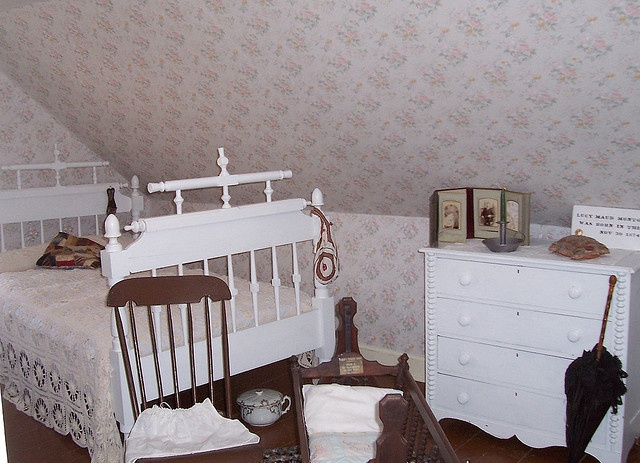Describe the objects in this image and their specific colors. I can see bed in gray, darkgray, and lightgray tones, chair in gray, darkgray, lightgray, maroon, and black tones, and umbrella in gray, black, maroon, and darkgray tones in this image. 